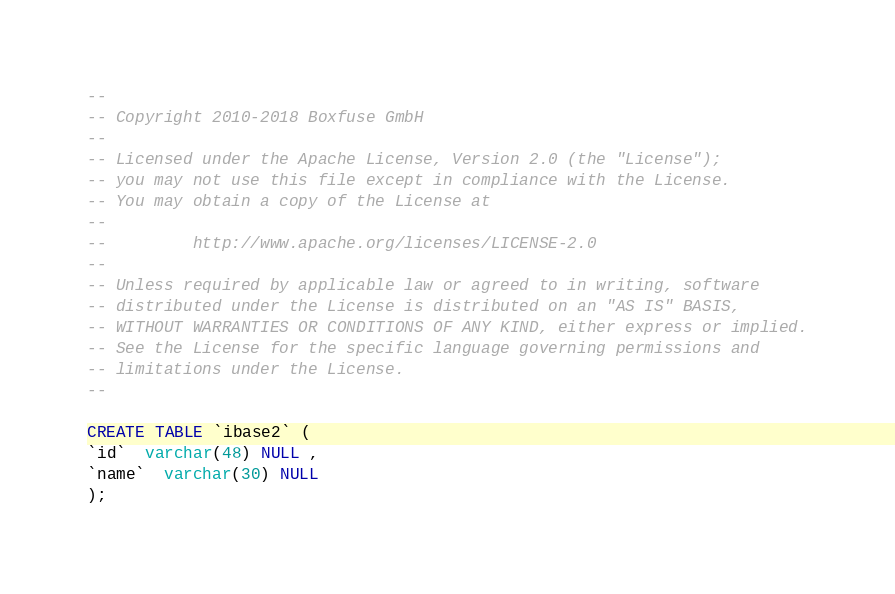<code> <loc_0><loc_0><loc_500><loc_500><_SQL_>--
-- Copyright 2010-2018 Boxfuse GmbH
--
-- Licensed under the Apache License, Version 2.0 (the "License");
-- you may not use this file except in compliance with the License.
-- You may obtain a copy of the License at
--
--         http://www.apache.org/licenses/LICENSE-2.0
--
-- Unless required by applicable law or agreed to in writing, software
-- distributed under the License is distributed on an "AS IS" BASIS,
-- WITHOUT WARRANTIES OR CONDITIONS OF ANY KIND, either express or implied.
-- See the License for the specific language governing permissions and
-- limitations under the License.
--

CREATE TABLE `ibase2` (
`id`  varchar(48) NULL ,
`name`  varchar(30) NULL 
);</code> 